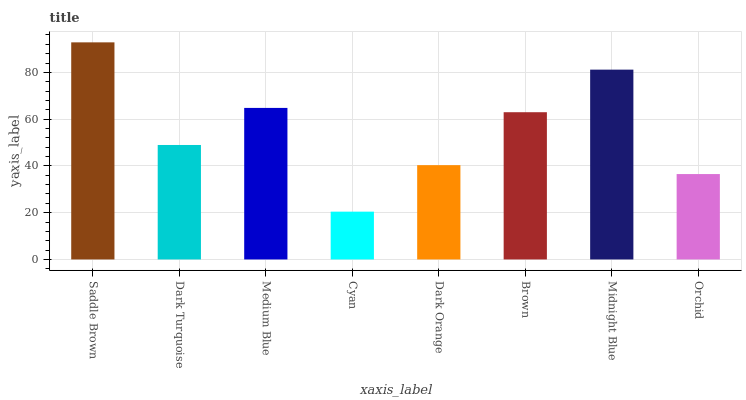Is Cyan the minimum?
Answer yes or no. Yes. Is Saddle Brown the maximum?
Answer yes or no. Yes. Is Dark Turquoise the minimum?
Answer yes or no. No. Is Dark Turquoise the maximum?
Answer yes or no. No. Is Saddle Brown greater than Dark Turquoise?
Answer yes or no. Yes. Is Dark Turquoise less than Saddle Brown?
Answer yes or no. Yes. Is Dark Turquoise greater than Saddle Brown?
Answer yes or no. No. Is Saddle Brown less than Dark Turquoise?
Answer yes or no. No. Is Brown the high median?
Answer yes or no. Yes. Is Dark Turquoise the low median?
Answer yes or no. Yes. Is Orchid the high median?
Answer yes or no. No. Is Cyan the low median?
Answer yes or no. No. 